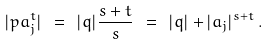<formula> <loc_0><loc_0><loc_500><loc_500>| p a _ { j } ^ { t } | \ = \ | q | \frac { s + t } { s } \ = \ | q | + | a _ { j } | ^ { s + t } \, .</formula> 